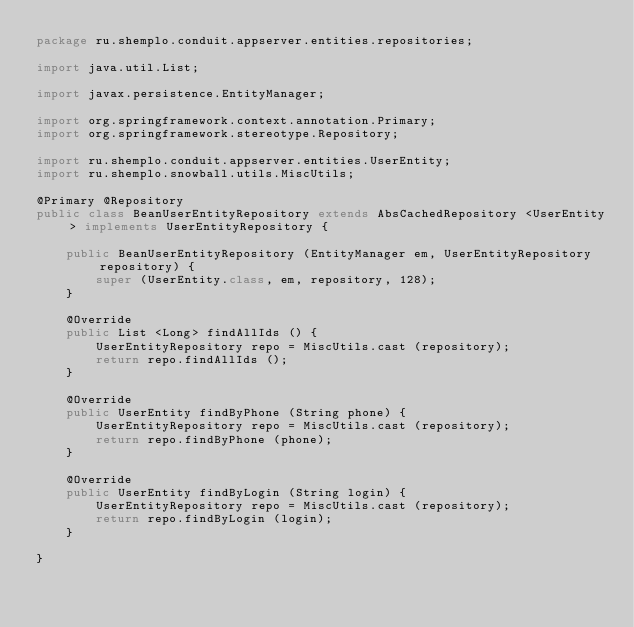Convert code to text. <code><loc_0><loc_0><loc_500><loc_500><_Java_>package ru.shemplo.conduit.appserver.entities.repositories;

import java.util.List;

import javax.persistence.EntityManager;

import org.springframework.context.annotation.Primary;
import org.springframework.stereotype.Repository;

import ru.shemplo.conduit.appserver.entities.UserEntity;
import ru.shemplo.snowball.utils.MiscUtils;

@Primary @Repository
public class BeanUserEntityRepository extends AbsCachedRepository <UserEntity> implements UserEntityRepository {

    public BeanUserEntityRepository (EntityManager em, UserEntityRepository repository) {
        super (UserEntity.class, em, repository, 128);
    }

    @Override
    public List <Long> findAllIds () {
        UserEntityRepository repo = MiscUtils.cast (repository);
        return repo.findAllIds ();
    }

    @Override
    public UserEntity findByPhone (String phone) {
        UserEntityRepository repo = MiscUtils.cast (repository);
        return repo.findByPhone (phone);
    }

    @Override
    public UserEntity findByLogin (String login) {
        UserEntityRepository repo = MiscUtils.cast (repository);
        return repo.findByLogin (login);
    }
    
}
</code> 